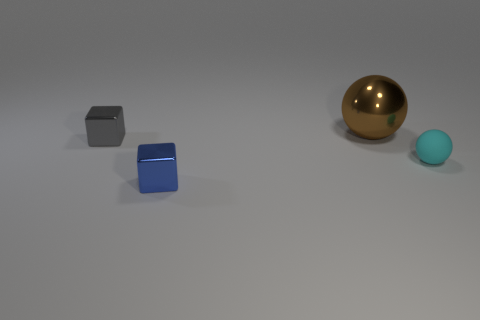Is there any other thing that is made of the same material as the tiny cyan object?
Ensure brevity in your answer.  No. Is there a small matte cube of the same color as the small ball?
Provide a short and direct response. No. What number of tiny things are blue cubes or gray metal objects?
Offer a terse response. 2. Is the material of the tiny thing on the right side of the small blue metallic block the same as the blue cube?
Offer a very short reply. No. There is a object that is to the left of the small shiny thing that is in front of the shiny cube behind the tiny blue shiny thing; what is its shape?
Offer a very short reply. Cube. What number of purple objects are either small metal blocks or tiny matte things?
Give a very brief answer. 0. Are there an equal number of large metal balls in front of the tiny gray metal object and tiny gray things behind the large thing?
Keep it short and to the point. Yes. Is the shape of the tiny object in front of the tiny rubber thing the same as the thing that is on the right side of the large brown shiny sphere?
Your answer should be compact. No. Is there any other thing that has the same shape as the brown object?
Make the answer very short. Yes. There is another blue object that is the same material as the large thing; what is its shape?
Your answer should be compact. Cube. 